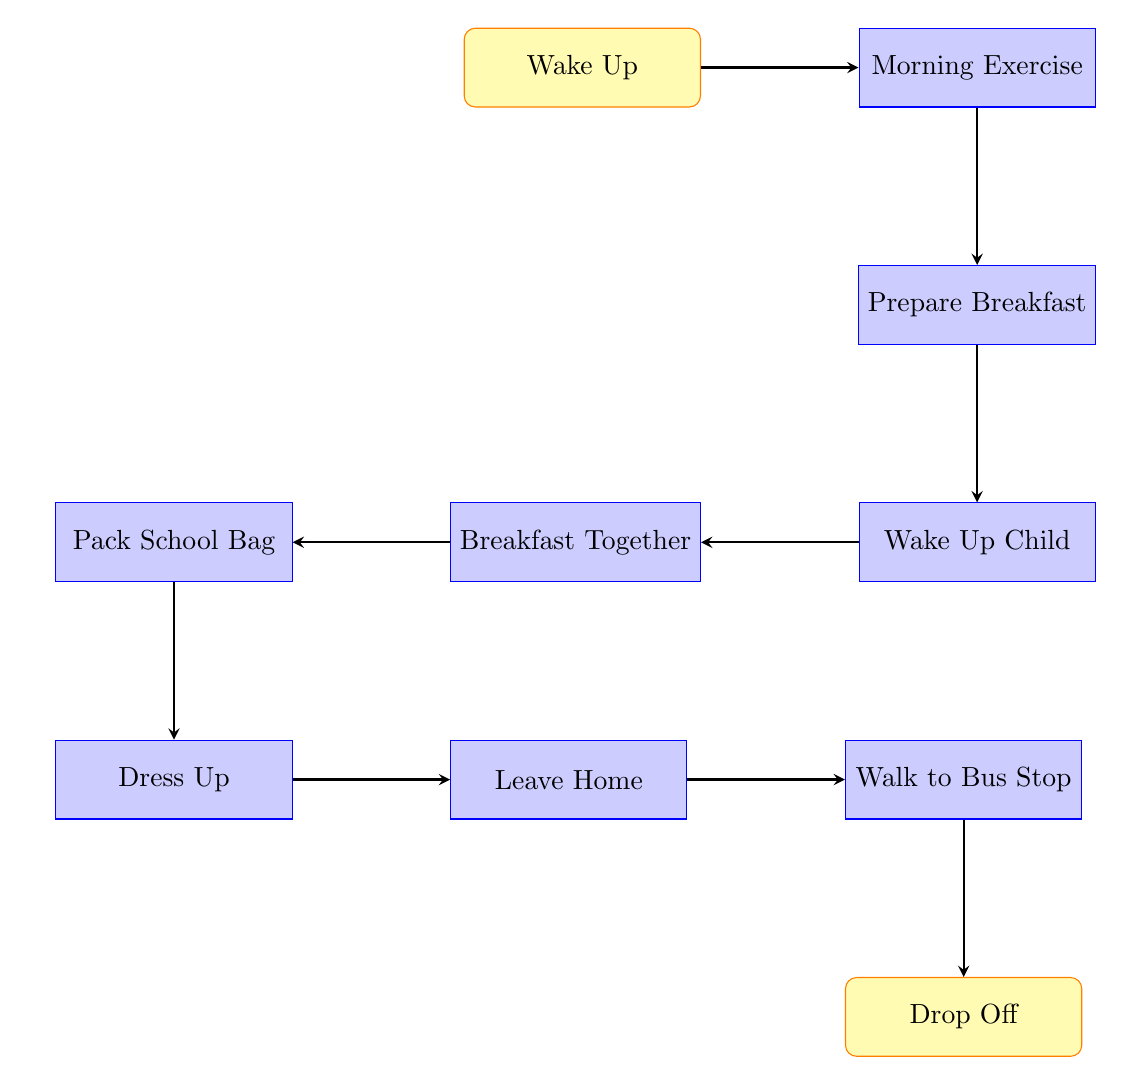What is the first step in the morning routine? The diagram indicates that the first step in the morning routine is "Wake Up", which is the initial action leading to subsequent steps.
Answer: Wake Up What time does the child wake up? According to the diagram, the step "Wake Up Child" occurs at 7:00 AM, which is the specific time mentioned for waking up the child.
Answer: 7:00 AM How many steps are there in total? The diagram lists a total of 10 steps, which includes all the activities leading up to the drop-off.
Answer: 10 What do you do right after "Prepare Breakfast"? The next step following "Prepare Breakfast" is "Wake Up Child," indicating that waking up the child is the immediate action taken afterwards.
Answer: Wake Up Child What is the final action in the morning routine? The last action depicted in the diagram is "Drop Off," which signifies the completion of the morning routine with the child being dropped off at school.
Answer: Drop Off How does one get to "Dress Up"? The flow progresses from "Pack School Bag" directly to "Dress Up," indicating that packing the school bag occurs before helping the child dress.
Answer: Pack School Bag What meal is prepared during the morning routine? The step labeled "Prepare Breakfast" specifies that a traditional Indian breakfast is made, highlighting the cultural aspect of the meal prepared.
Answer: Breakfast What happens after "Leave Home"? The subsequent step after "Leave Home" is "Walk to Bus Stop," showing the flow of actions towards getting the child to school.
Answer: Walk to Bus Stop Which steps involve interaction with the child? The steps "Wake Up Child," "Breakfast Together," "Dress Up," and "Drop Off" all involve direct interaction with the child during the morning routine.
Answer: 4 steps 